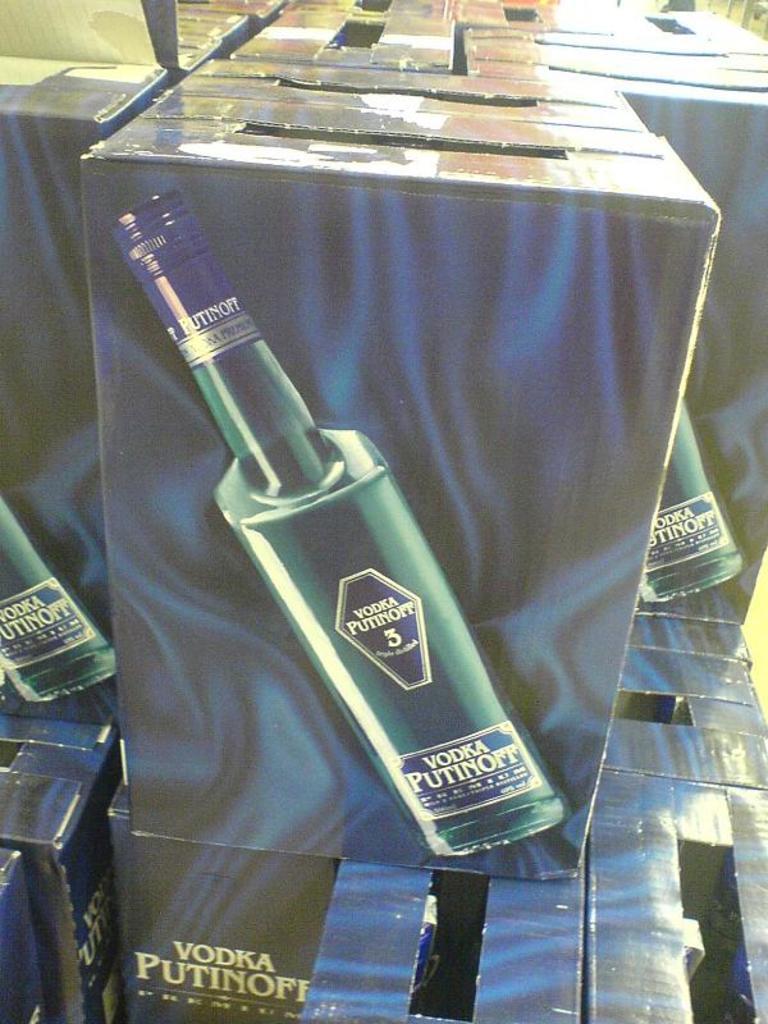What kind of drink is in the bottle?
Offer a very short reply. Vodka. What number is on the label?
Offer a terse response. 3. 